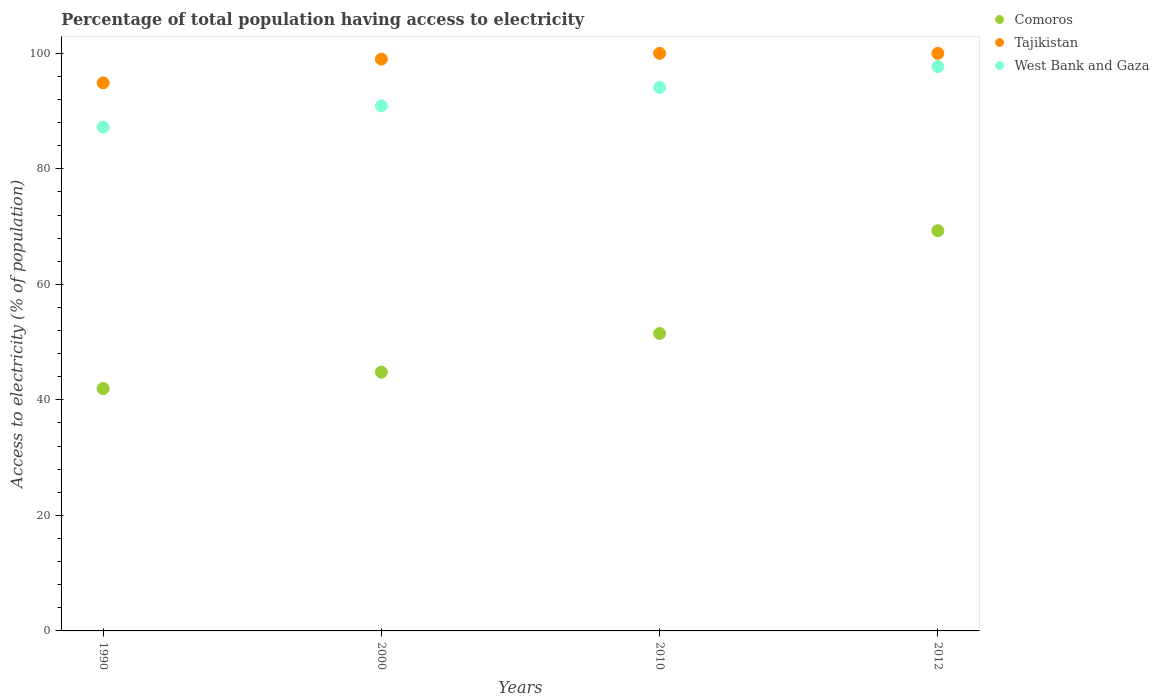Is the number of dotlines equal to the number of legend labels?
Give a very brief answer. Yes. Across all years, what is the maximum percentage of population that have access to electricity in Comoros?
Your answer should be very brief. 69.3. Across all years, what is the minimum percentage of population that have access to electricity in Tajikistan?
Provide a succinct answer. 94.89. In which year was the percentage of population that have access to electricity in Tajikistan minimum?
Offer a very short reply. 1990. What is the total percentage of population that have access to electricity in West Bank and Gaza in the graph?
Your response must be concise. 369.92. What is the difference between the percentage of population that have access to electricity in West Bank and Gaza in 1990 and that in 2012?
Your answer should be compact. -10.47. What is the difference between the percentage of population that have access to electricity in Comoros in 1990 and the percentage of population that have access to electricity in Tajikistan in 2010?
Your answer should be very brief. -58.04. What is the average percentage of population that have access to electricity in Comoros per year?
Your answer should be compact. 51.89. In the year 2012, what is the difference between the percentage of population that have access to electricity in West Bank and Gaza and percentage of population that have access to electricity in Tajikistan?
Keep it short and to the point. -2.3. What is the ratio of the percentage of population that have access to electricity in Tajikistan in 1990 to that in 2010?
Keep it short and to the point. 0.95. What is the difference between the highest and the second highest percentage of population that have access to electricity in West Bank and Gaza?
Offer a terse response. 3.6. What is the difference between the highest and the lowest percentage of population that have access to electricity in West Bank and Gaza?
Your answer should be compact. 10.47. In how many years, is the percentage of population that have access to electricity in Tajikistan greater than the average percentage of population that have access to electricity in Tajikistan taken over all years?
Ensure brevity in your answer.  3. Is the sum of the percentage of population that have access to electricity in Tajikistan in 1990 and 2010 greater than the maximum percentage of population that have access to electricity in West Bank and Gaza across all years?
Offer a terse response. Yes. Does the percentage of population that have access to electricity in Tajikistan monotonically increase over the years?
Keep it short and to the point. No. Is the percentage of population that have access to electricity in Comoros strictly less than the percentage of population that have access to electricity in West Bank and Gaza over the years?
Ensure brevity in your answer.  Yes. How many years are there in the graph?
Your answer should be very brief. 4. Are the values on the major ticks of Y-axis written in scientific E-notation?
Provide a short and direct response. No. Does the graph contain grids?
Give a very brief answer. No. How many legend labels are there?
Keep it short and to the point. 3. What is the title of the graph?
Your response must be concise. Percentage of total population having access to electricity. Does "Iran" appear as one of the legend labels in the graph?
Make the answer very short. No. What is the label or title of the X-axis?
Offer a terse response. Years. What is the label or title of the Y-axis?
Provide a succinct answer. Access to electricity (% of population). What is the Access to electricity (% of population) in Comoros in 1990?
Give a very brief answer. 41.96. What is the Access to electricity (% of population) of Tajikistan in 1990?
Ensure brevity in your answer.  94.89. What is the Access to electricity (% of population) in West Bank and Gaza in 1990?
Ensure brevity in your answer.  87.23. What is the Access to electricity (% of population) of Comoros in 2000?
Make the answer very short. 44.8. What is the Access to electricity (% of population) of West Bank and Gaza in 2000?
Ensure brevity in your answer.  90.9. What is the Access to electricity (% of population) of Comoros in 2010?
Your answer should be very brief. 51.5. What is the Access to electricity (% of population) in Tajikistan in 2010?
Your answer should be very brief. 100. What is the Access to electricity (% of population) of West Bank and Gaza in 2010?
Your answer should be compact. 94.1. What is the Access to electricity (% of population) in Comoros in 2012?
Your answer should be compact. 69.3. What is the Access to electricity (% of population) in West Bank and Gaza in 2012?
Offer a very short reply. 97.7. Across all years, what is the maximum Access to electricity (% of population) of Comoros?
Offer a terse response. 69.3. Across all years, what is the maximum Access to electricity (% of population) in West Bank and Gaza?
Make the answer very short. 97.7. Across all years, what is the minimum Access to electricity (% of population) of Comoros?
Provide a succinct answer. 41.96. Across all years, what is the minimum Access to electricity (% of population) of Tajikistan?
Offer a very short reply. 94.89. Across all years, what is the minimum Access to electricity (% of population) in West Bank and Gaza?
Ensure brevity in your answer.  87.23. What is the total Access to electricity (% of population) in Comoros in the graph?
Make the answer very short. 207.56. What is the total Access to electricity (% of population) in Tajikistan in the graph?
Keep it short and to the point. 393.89. What is the total Access to electricity (% of population) of West Bank and Gaza in the graph?
Make the answer very short. 369.92. What is the difference between the Access to electricity (% of population) of Comoros in 1990 and that in 2000?
Provide a succinct answer. -2.84. What is the difference between the Access to electricity (% of population) of Tajikistan in 1990 and that in 2000?
Make the answer very short. -4.11. What is the difference between the Access to electricity (% of population) in West Bank and Gaza in 1990 and that in 2000?
Ensure brevity in your answer.  -3.67. What is the difference between the Access to electricity (% of population) in Comoros in 1990 and that in 2010?
Offer a very short reply. -9.54. What is the difference between the Access to electricity (% of population) in Tajikistan in 1990 and that in 2010?
Your answer should be compact. -5.11. What is the difference between the Access to electricity (% of population) of West Bank and Gaza in 1990 and that in 2010?
Keep it short and to the point. -6.87. What is the difference between the Access to electricity (% of population) of Comoros in 1990 and that in 2012?
Provide a short and direct response. -27.34. What is the difference between the Access to electricity (% of population) of Tajikistan in 1990 and that in 2012?
Make the answer very short. -5.11. What is the difference between the Access to electricity (% of population) in West Bank and Gaza in 1990 and that in 2012?
Your response must be concise. -10.47. What is the difference between the Access to electricity (% of population) of West Bank and Gaza in 2000 and that in 2010?
Ensure brevity in your answer.  -3.2. What is the difference between the Access to electricity (% of population) in Comoros in 2000 and that in 2012?
Give a very brief answer. -24.5. What is the difference between the Access to electricity (% of population) of Tajikistan in 2000 and that in 2012?
Make the answer very short. -1. What is the difference between the Access to electricity (% of population) of West Bank and Gaza in 2000 and that in 2012?
Provide a short and direct response. -6.8. What is the difference between the Access to electricity (% of population) of Comoros in 2010 and that in 2012?
Your answer should be very brief. -17.8. What is the difference between the Access to electricity (% of population) in West Bank and Gaza in 2010 and that in 2012?
Your answer should be very brief. -3.6. What is the difference between the Access to electricity (% of population) of Comoros in 1990 and the Access to electricity (% of population) of Tajikistan in 2000?
Provide a short and direct response. -57.04. What is the difference between the Access to electricity (% of population) of Comoros in 1990 and the Access to electricity (% of population) of West Bank and Gaza in 2000?
Your answer should be very brief. -48.94. What is the difference between the Access to electricity (% of population) of Tajikistan in 1990 and the Access to electricity (% of population) of West Bank and Gaza in 2000?
Your answer should be compact. 3.99. What is the difference between the Access to electricity (% of population) in Comoros in 1990 and the Access to electricity (% of population) in Tajikistan in 2010?
Keep it short and to the point. -58.04. What is the difference between the Access to electricity (% of population) of Comoros in 1990 and the Access to electricity (% of population) of West Bank and Gaza in 2010?
Offer a very short reply. -52.14. What is the difference between the Access to electricity (% of population) of Tajikistan in 1990 and the Access to electricity (% of population) of West Bank and Gaza in 2010?
Make the answer very short. 0.79. What is the difference between the Access to electricity (% of population) of Comoros in 1990 and the Access to electricity (% of population) of Tajikistan in 2012?
Give a very brief answer. -58.04. What is the difference between the Access to electricity (% of population) in Comoros in 1990 and the Access to electricity (% of population) in West Bank and Gaza in 2012?
Your answer should be compact. -55.74. What is the difference between the Access to electricity (% of population) in Tajikistan in 1990 and the Access to electricity (% of population) in West Bank and Gaza in 2012?
Provide a short and direct response. -2.81. What is the difference between the Access to electricity (% of population) in Comoros in 2000 and the Access to electricity (% of population) in Tajikistan in 2010?
Ensure brevity in your answer.  -55.2. What is the difference between the Access to electricity (% of population) in Comoros in 2000 and the Access to electricity (% of population) in West Bank and Gaza in 2010?
Make the answer very short. -49.3. What is the difference between the Access to electricity (% of population) in Tajikistan in 2000 and the Access to electricity (% of population) in West Bank and Gaza in 2010?
Provide a succinct answer. 4.9. What is the difference between the Access to electricity (% of population) in Comoros in 2000 and the Access to electricity (% of population) in Tajikistan in 2012?
Make the answer very short. -55.2. What is the difference between the Access to electricity (% of population) of Comoros in 2000 and the Access to electricity (% of population) of West Bank and Gaza in 2012?
Ensure brevity in your answer.  -52.9. What is the difference between the Access to electricity (% of population) in Tajikistan in 2000 and the Access to electricity (% of population) in West Bank and Gaza in 2012?
Make the answer very short. 1.3. What is the difference between the Access to electricity (% of population) of Comoros in 2010 and the Access to electricity (% of population) of Tajikistan in 2012?
Ensure brevity in your answer.  -48.5. What is the difference between the Access to electricity (% of population) in Comoros in 2010 and the Access to electricity (% of population) in West Bank and Gaza in 2012?
Provide a succinct answer. -46.2. What is the difference between the Access to electricity (% of population) in Tajikistan in 2010 and the Access to electricity (% of population) in West Bank and Gaza in 2012?
Your answer should be very brief. 2.3. What is the average Access to electricity (% of population) of Comoros per year?
Offer a very short reply. 51.89. What is the average Access to electricity (% of population) in Tajikistan per year?
Your response must be concise. 98.47. What is the average Access to electricity (% of population) in West Bank and Gaza per year?
Offer a terse response. 92.48. In the year 1990, what is the difference between the Access to electricity (% of population) of Comoros and Access to electricity (% of population) of Tajikistan?
Offer a terse response. -52.93. In the year 1990, what is the difference between the Access to electricity (% of population) in Comoros and Access to electricity (% of population) in West Bank and Gaza?
Offer a very short reply. -45.27. In the year 1990, what is the difference between the Access to electricity (% of population) in Tajikistan and Access to electricity (% of population) in West Bank and Gaza?
Give a very brief answer. 7.66. In the year 2000, what is the difference between the Access to electricity (% of population) of Comoros and Access to electricity (% of population) of Tajikistan?
Ensure brevity in your answer.  -54.2. In the year 2000, what is the difference between the Access to electricity (% of population) in Comoros and Access to electricity (% of population) in West Bank and Gaza?
Your answer should be compact. -46.1. In the year 2000, what is the difference between the Access to electricity (% of population) of Tajikistan and Access to electricity (% of population) of West Bank and Gaza?
Give a very brief answer. 8.1. In the year 2010, what is the difference between the Access to electricity (% of population) of Comoros and Access to electricity (% of population) of Tajikistan?
Keep it short and to the point. -48.5. In the year 2010, what is the difference between the Access to electricity (% of population) in Comoros and Access to electricity (% of population) in West Bank and Gaza?
Your answer should be compact. -42.6. In the year 2010, what is the difference between the Access to electricity (% of population) in Tajikistan and Access to electricity (% of population) in West Bank and Gaza?
Make the answer very short. 5.9. In the year 2012, what is the difference between the Access to electricity (% of population) in Comoros and Access to electricity (% of population) in Tajikistan?
Your answer should be compact. -30.7. In the year 2012, what is the difference between the Access to electricity (% of population) in Comoros and Access to electricity (% of population) in West Bank and Gaza?
Your response must be concise. -28.4. In the year 2012, what is the difference between the Access to electricity (% of population) of Tajikistan and Access to electricity (% of population) of West Bank and Gaza?
Provide a succinct answer. 2.3. What is the ratio of the Access to electricity (% of population) in Comoros in 1990 to that in 2000?
Offer a terse response. 0.94. What is the ratio of the Access to electricity (% of population) of Tajikistan in 1990 to that in 2000?
Offer a terse response. 0.96. What is the ratio of the Access to electricity (% of population) in West Bank and Gaza in 1990 to that in 2000?
Make the answer very short. 0.96. What is the ratio of the Access to electricity (% of population) in Comoros in 1990 to that in 2010?
Offer a terse response. 0.81. What is the ratio of the Access to electricity (% of population) in Tajikistan in 1990 to that in 2010?
Give a very brief answer. 0.95. What is the ratio of the Access to electricity (% of population) of West Bank and Gaza in 1990 to that in 2010?
Provide a succinct answer. 0.93. What is the ratio of the Access to electricity (% of population) of Comoros in 1990 to that in 2012?
Your answer should be compact. 0.61. What is the ratio of the Access to electricity (% of population) of Tajikistan in 1990 to that in 2012?
Make the answer very short. 0.95. What is the ratio of the Access to electricity (% of population) of West Bank and Gaza in 1990 to that in 2012?
Your answer should be compact. 0.89. What is the ratio of the Access to electricity (% of population) of Comoros in 2000 to that in 2010?
Provide a succinct answer. 0.87. What is the ratio of the Access to electricity (% of population) in Tajikistan in 2000 to that in 2010?
Offer a very short reply. 0.99. What is the ratio of the Access to electricity (% of population) of Comoros in 2000 to that in 2012?
Provide a succinct answer. 0.65. What is the ratio of the Access to electricity (% of population) in West Bank and Gaza in 2000 to that in 2012?
Ensure brevity in your answer.  0.93. What is the ratio of the Access to electricity (% of population) in Comoros in 2010 to that in 2012?
Your answer should be very brief. 0.74. What is the ratio of the Access to electricity (% of population) of West Bank and Gaza in 2010 to that in 2012?
Offer a terse response. 0.96. What is the difference between the highest and the second highest Access to electricity (% of population) of Comoros?
Your answer should be very brief. 17.8. What is the difference between the highest and the second highest Access to electricity (% of population) of Tajikistan?
Your answer should be very brief. 0. What is the difference between the highest and the second highest Access to electricity (% of population) in West Bank and Gaza?
Your response must be concise. 3.6. What is the difference between the highest and the lowest Access to electricity (% of population) in Comoros?
Offer a very short reply. 27.34. What is the difference between the highest and the lowest Access to electricity (% of population) of Tajikistan?
Ensure brevity in your answer.  5.11. What is the difference between the highest and the lowest Access to electricity (% of population) in West Bank and Gaza?
Provide a succinct answer. 10.47. 